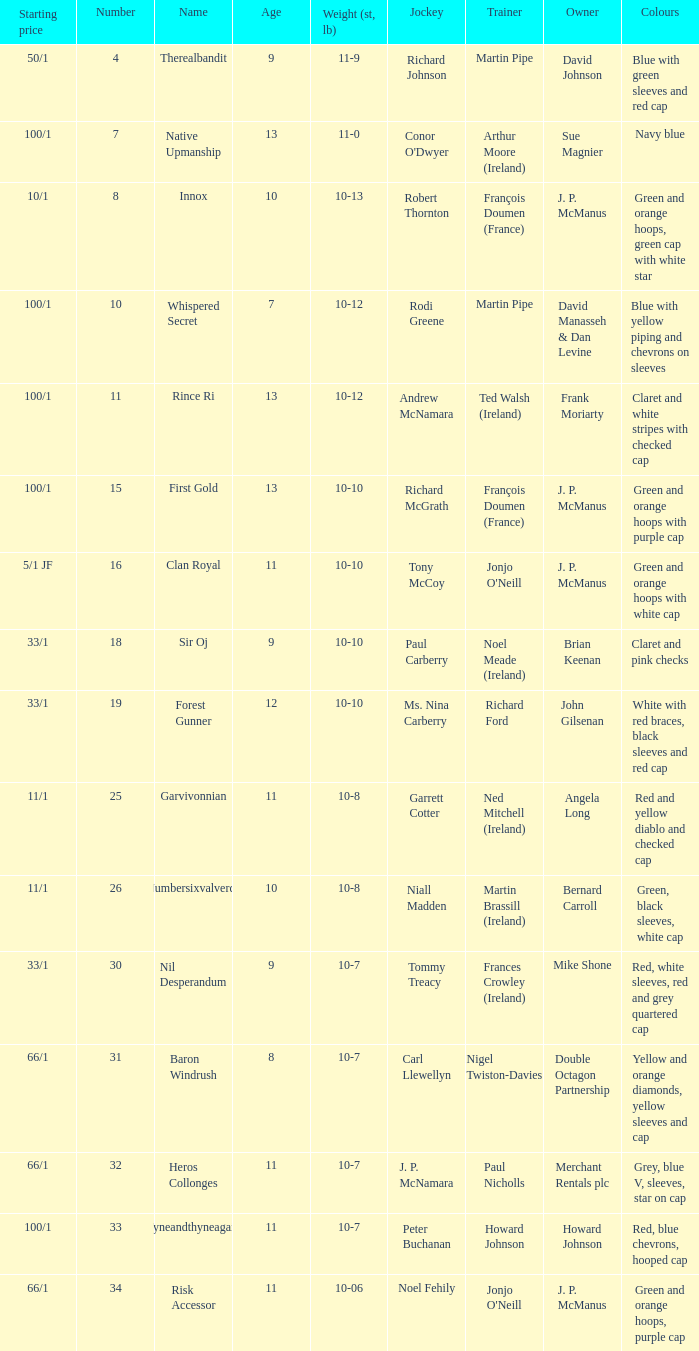What was the appellation that had an initial rate of 11/1 and a horseman named garrett cotter? Garvivonnian. 